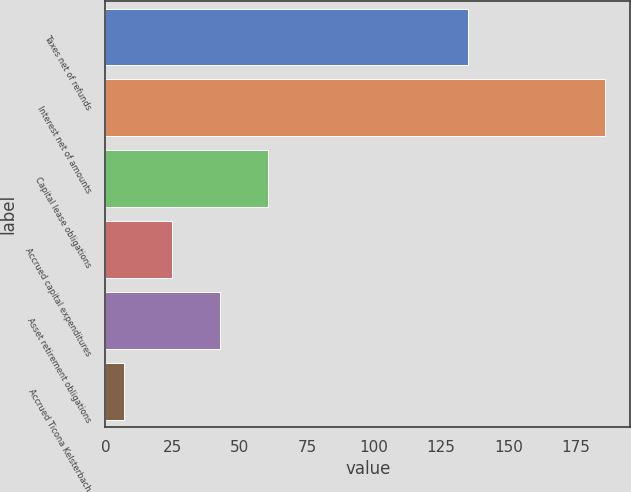Convert chart to OTSL. <chart><loc_0><loc_0><loc_500><loc_500><bar_chart><fcel>Taxes net of refunds<fcel>Interest net of amounts<fcel>Capital lease obligations<fcel>Accrued capital expenditures<fcel>Asset retirement obligations<fcel>Accrued Ticona Kelsterbach<nl><fcel>135<fcel>186<fcel>60.7<fcel>24.9<fcel>42.8<fcel>7<nl></chart> 